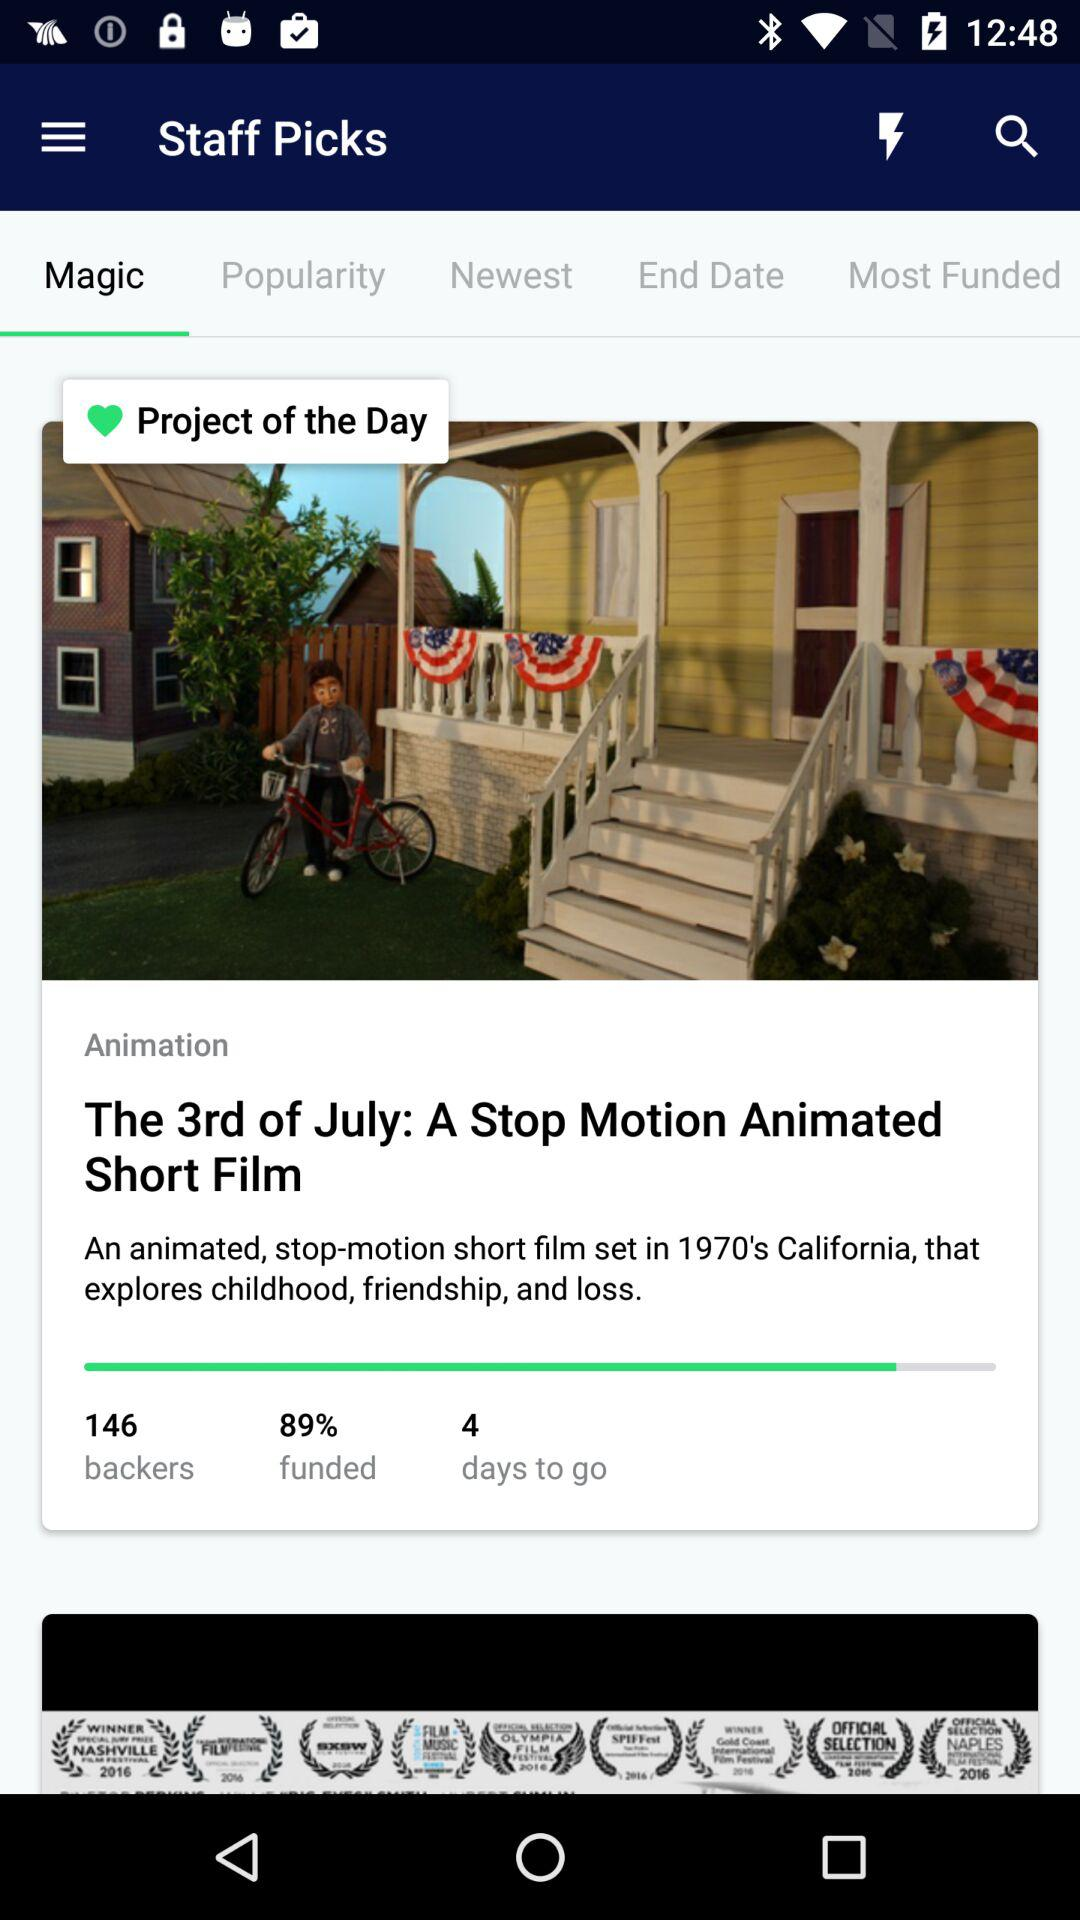Which tab is selected? The selected tab is "Magic". 